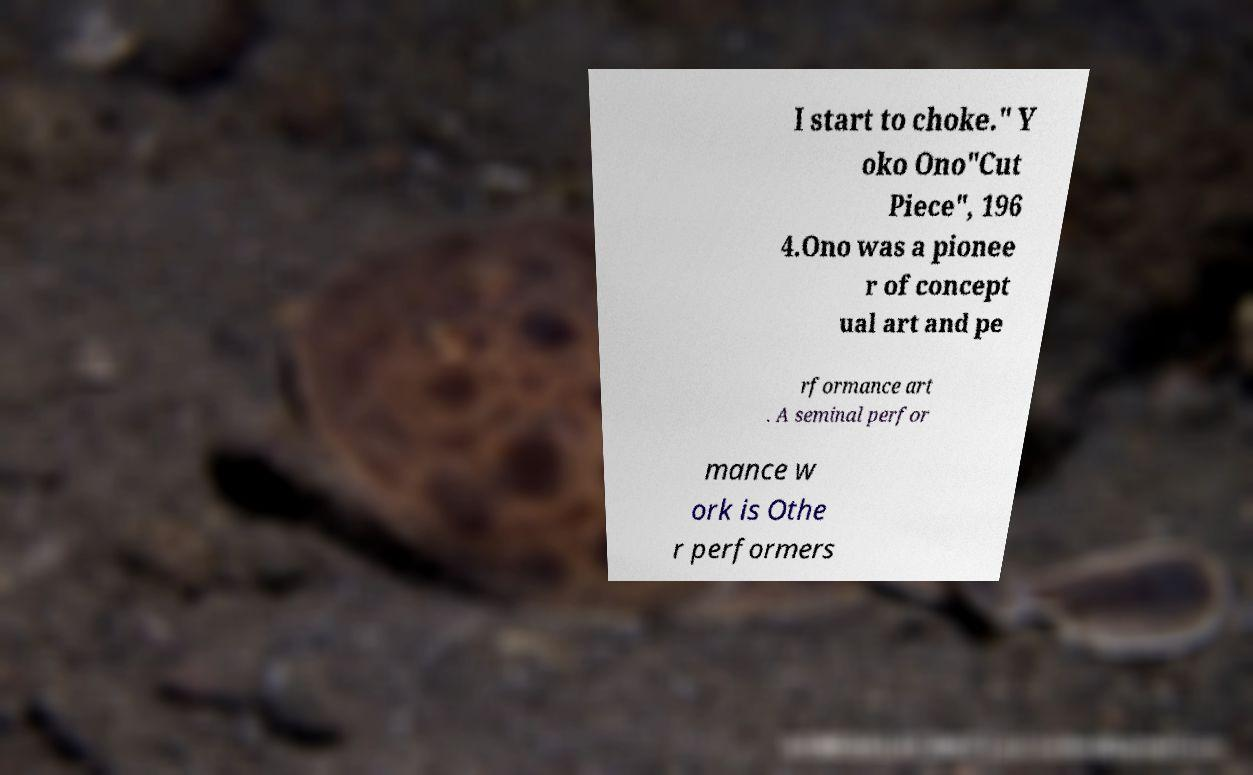Please read and relay the text visible in this image. What does it say? I start to choke." Y oko Ono"Cut Piece", 196 4.Ono was a pionee r of concept ual art and pe rformance art . A seminal perfor mance w ork is Othe r performers 